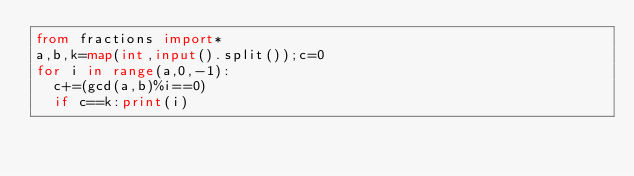<code> <loc_0><loc_0><loc_500><loc_500><_Python_>from fractions import*
a,b,k=map(int,input().split());c=0
for i in range(a,0,-1):
  c+=(gcd(a,b)%i==0)
  if c==k:print(i)</code> 